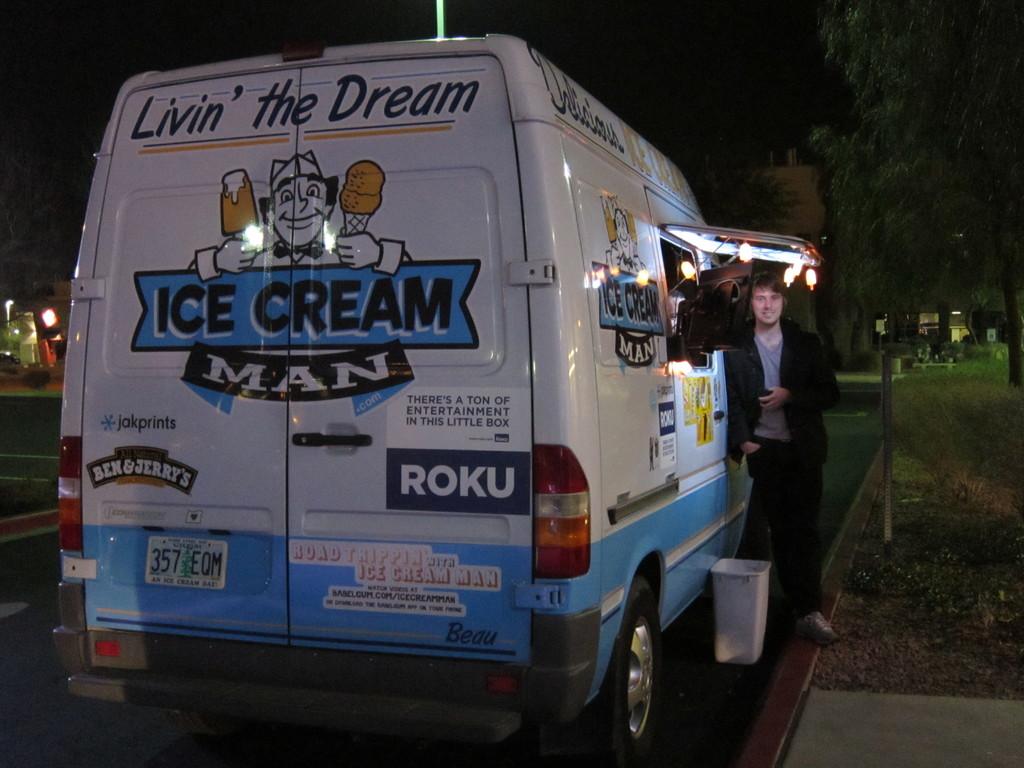What is being lived?
Your answer should be compact. The dream. What man is mentioned on the back of the truck?
Give a very brief answer. Ice cream man. 